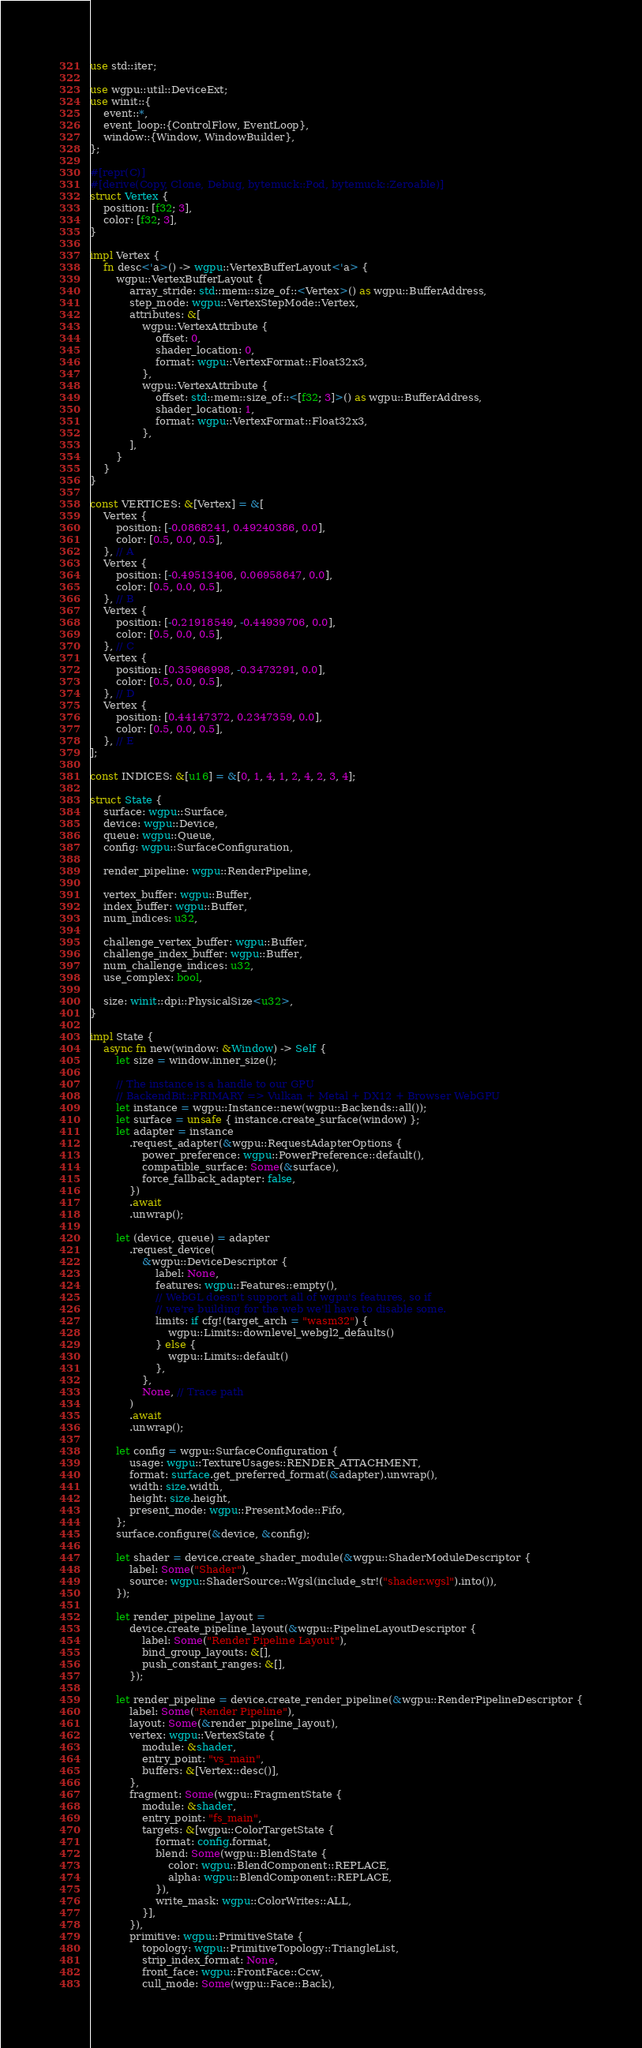Convert code to text. <code><loc_0><loc_0><loc_500><loc_500><_Rust_>use std::iter;

use wgpu::util::DeviceExt;
use winit::{
    event::*,
    event_loop::{ControlFlow, EventLoop},
    window::{Window, WindowBuilder},
};

#[repr(C)]
#[derive(Copy, Clone, Debug, bytemuck::Pod, bytemuck::Zeroable)]
struct Vertex {
    position: [f32; 3],
    color: [f32; 3],
}

impl Vertex {
    fn desc<'a>() -> wgpu::VertexBufferLayout<'a> {
        wgpu::VertexBufferLayout {
            array_stride: std::mem::size_of::<Vertex>() as wgpu::BufferAddress,
            step_mode: wgpu::VertexStepMode::Vertex,
            attributes: &[
                wgpu::VertexAttribute {
                    offset: 0,
                    shader_location: 0,
                    format: wgpu::VertexFormat::Float32x3,
                },
                wgpu::VertexAttribute {
                    offset: std::mem::size_of::<[f32; 3]>() as wgpu::BufferAddress,
                    shader_location: 1,
                    format: wgpu::VertexFormat::Float32x3,
                },
            ],
        }
    }
}

const VERTICES: &[Vertex] = &[
    Vertex {
        position: [-0.0868241, 0.49240386, 0.0],
        color: [0.5, 0.0, 0.5],
    }, // A
    Vertex {
        position: [-0.49513406, 0.06958647, 0.0],
        color: [0.5, 0.0, 0.5],
    }, // B
    Vertex {
        position: [-0.21918549, -0.44939706, 0.0],
        color: [0.5, 0.0, 0.5],
    }, // C
    Vertex {
        position: [0.35966998, -0.3473291, 0.0],
        color: [0.5, 0.0, 0.5],
    }, // D
    Vertex {
        position: [0.44147372, 0.2347359, 0.0],
        color: [0.5, 0.0, 0.5],
    }, // E
];

const INDICES: &[u16] = &[0, 1, 4, 1, 2, 4, 2, 3, 4];

struct State {
    surface: wgpu::Surface,
    device: wgpu::Device,
    queue: wgpu::Queue,
    config: wgpu::SurfaceConfiguration,

    render_pipeline: wgpu::RenderPipeline,

    vertex_buffer: wgpu::Buffer,
    index_buffer: wgpu::Buffer,
    num_indices: u32,

    challenge_vertex_buffer: wgpu::Buffer,
    challenge_index_buffer: wgpu::Buffer,
    num_challenge_indices: u32,
    use_complex: bool,

    size: winit::dpi::PhysicalSize<u32>,
}

impl State {
    async fn new(window: &Window) -> Self {
        let size = window.inner_size();

        // The instance is a handle to our GPU
        // BackendBit::PRIMARY => Vulkan + Metal + DX12 + Browser WebGPU
        let instance = wgpu::Instance::new(wgpu::Backends::all());
        let surface = unsafe { instance.create_surface(window) };
        let adapter = instance
            .request_adapter(&wgpu::RequestAdapterOptions {
                power_preference: wgpu::PowerPreference::default(),
                compatible_surface: Some(&surface),
                force_fallback_adapter: false,
            })
            .await
            .unwrap();

        let (device, queue) = adapter
            .request_device(
                &wgpu::DeviceDescriptor {
                    label: None,
                    features: wgpu::Features::empty(),
                    // WebGL doesn't support all of wgpu's features, so if
                    // we're building for the web we'll have to disable some.
                    limits: if cfg!(target_arch = "wasm32") {
                        wgpu::Limits::downlevel_webgl2_defaults()
                    } else {
                        wgpu::Limits::default()
                    },
                },
                None, // Trace path
            )
            .await
            .unwrap();

        let config = wgpu::SurfaceConfiguration {
            usage: wgpu::TextureUsages::RENDER_ATTACHMENT,
            format: surface.get_preferred_format(&adapter).unwrap(),
            width: size.width,
            height: size.height,
            present_mode: wgpu::PresentMode::Fifo,
        };
        surface.configure(&device, &config);

        let shader = device.create_shader_module(&wgpu::ShaderModuleDescriptor {
            label: Some("Shader"),
            source: wgpu::ShaderSource::Wgsl(include_str!("shader.wgsl").into()),
        });

        let render_pipeline_layout =
            device.create_pipeline_layout(&wgpu::PipelineLayoutDescriptor {
                label: Some("Render Pipeline Layout"),
                bind_group_layouts: &[],
                push_constant_ranges: &[],
            });

        let render_pipeline = device.create_render_pipeline(&wgpu::RenderPipelineDescriptor {
            label: Some("Render Pipeline"),
            layout: Some(&render_pipeline_layout),
            vertex: wgpu::VertexState {
                module: &shader,
                entry_point: "vs_main",
                buffers: &[Vertex::desc()],
            },
            fragment: Some(wgpu::FragmentState {
                module: &shader,
                entry_point: "fs_main",
                targets: &[wgpu::ColorTargetState {
                    format: config.format,
                    blend: Some(wgpu::BlendState {
                        color: wgpu::BlendComponent::REPLACE,
                        alpha: wgpu::BlendComponent::REPLACE,
                    }),
                    write_mask: wgpu::ColorWrites::ALL,
                }],
            }),
            primitive: wgpu::PrimitiveState {
                topology: wgpu::PrimitiveTopology::TriangleList,
                strip_index_format: None,
                front_face: wgpu::FrontFace::Ccw,
                cull_mode: Some(wgpu::Face::Back),</code> 